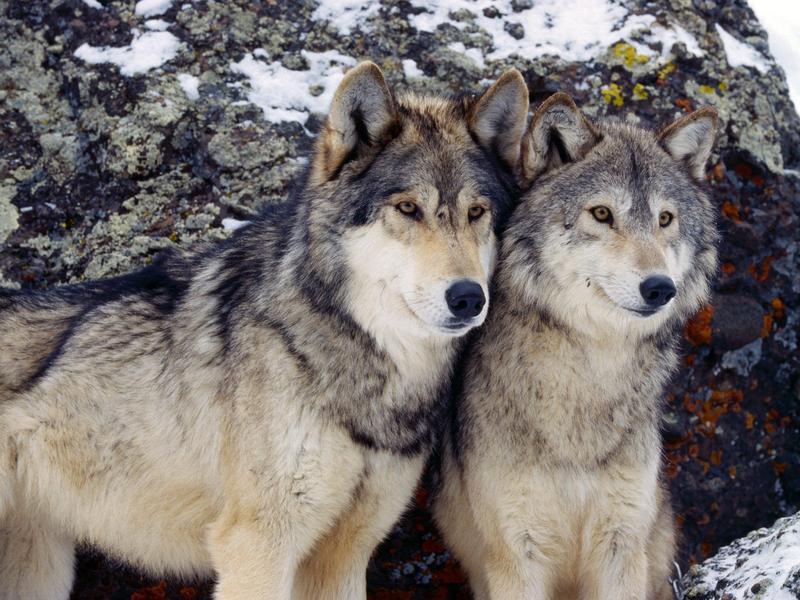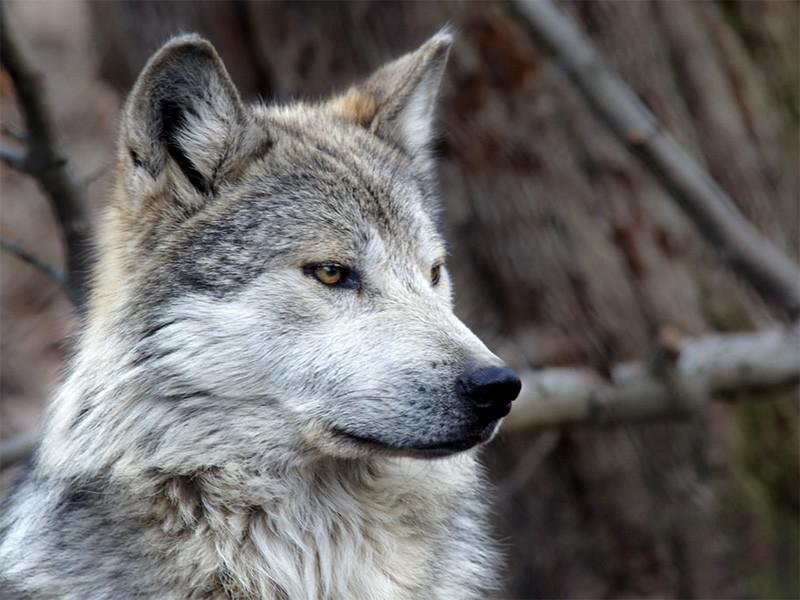The first image is the image on the left, the second image is the image on the right. Given the left and right images, does the statement "There is at least two wolves in the left image." hold true? Answer yes or no. Yes. The first image is the image on the left, the second image is the image on the right. For the images displayed, is the sentence "A camera-facing wolf has fangs bared in a fierce expression." factually correct? Answer yes or no. No. 